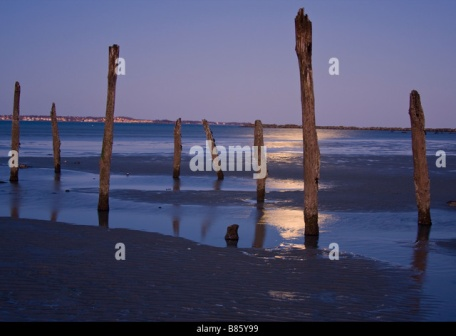What emotions does this image evoke for you? The image evokes a sense of calm and peaceful solitude. The serene setting of the beach at dusk, combined with the tranquil water reflecting the soft light of the setting sun, invites introspection and meditation. The weathered wooden poles, standing silently in a line, seem to tell a story of endurance and the passage of time, adding a touch of melancholy to the otherwise soothing scene. 